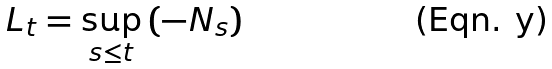<formula> <loc_0><loc_0><loc_500><loc_500>L _ { t } = \sup _ { s \leq t } \left ( - N _ { s } \right )</formula> 